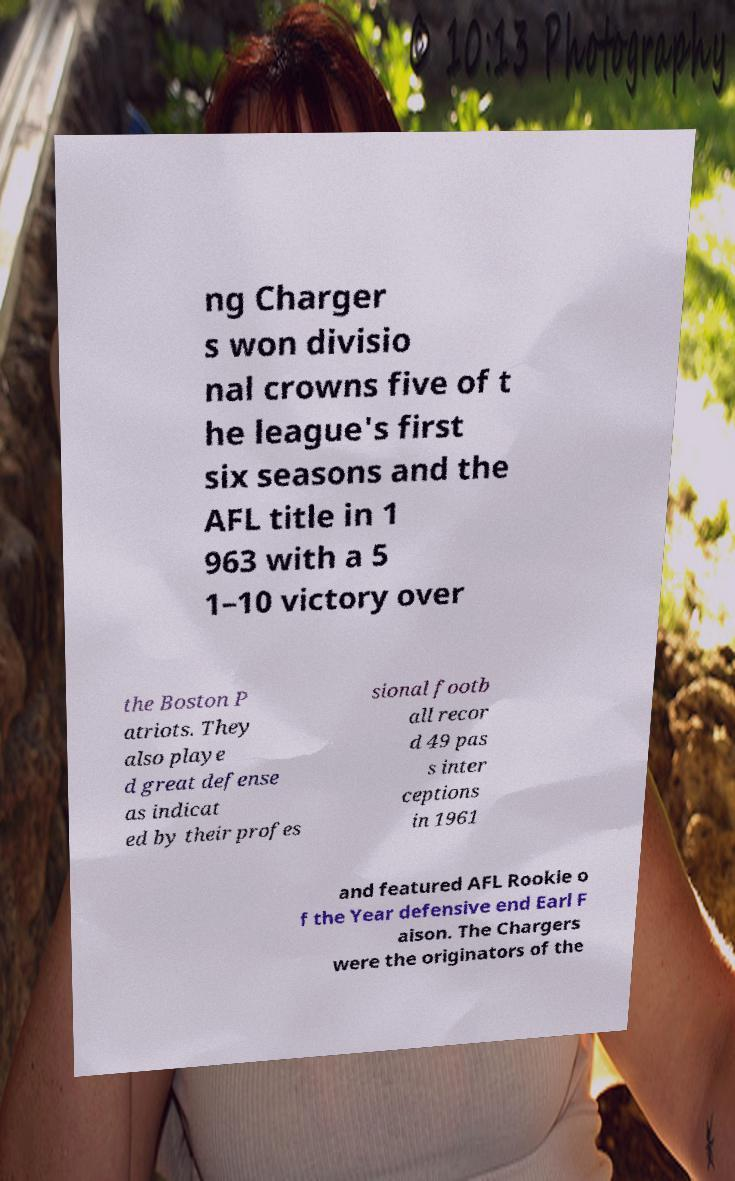Please read and relay the text visible in this image. What does it say? ng Charger s won divisio nal crowns five of t he league's first six seasons and the AFL title in 1 963 with a 5 1–10 victory over the Boston P atriots. They also playe d great defense as indicat ed by their profes sional footb all recor d 49 pas s inter ceptions in 1961 and featured AFL Rookie o f the Year defensive end Earl F aison. The Chargers were the originators of the 